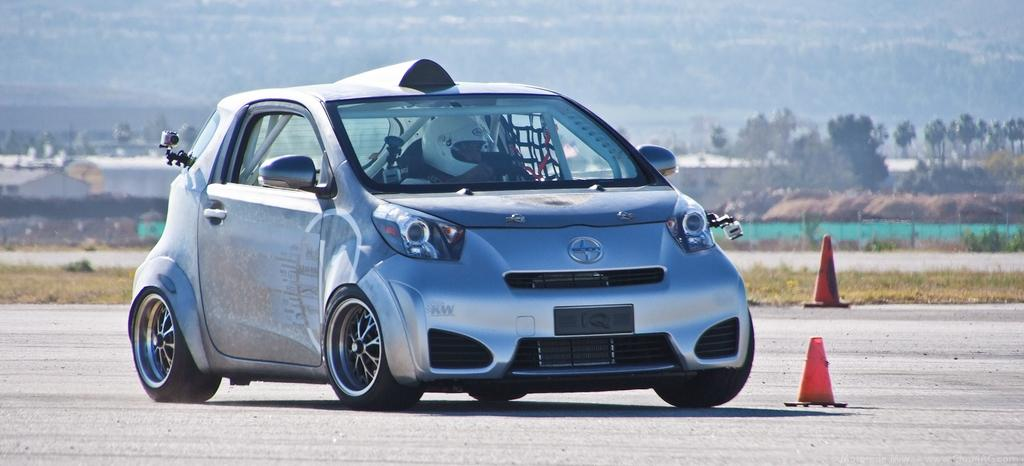What is the main subject in the center of the image? There is a car in the center of the image. Where is the car located? The car is on the road. What objects are present to guide or control traffic in the image? There are two traffic cones in the image. What type of natural environment can be seen in the background of the image? There are many trees, a fence, grass, and a hill visible in the background of the image. What type of vacation is the turkey taking in the image? There is no turkey present in the image, so it cannot be taking a vacation. 